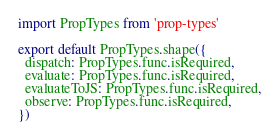Convert code to text. <code><loc_0><loc_0><loc_500><loc_500><_JavaScript_>import PropTypes from 'prop-types'

export default PropTypes.shape({
  dispatch: PropTypes.func.isRequired,
  evaluate: PropTypes.func.isRequired,
  evaluateToJS: PropTypes.func.isRequired,
  observe: PropTypes.func.isRequired,
})
</code> 